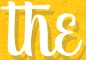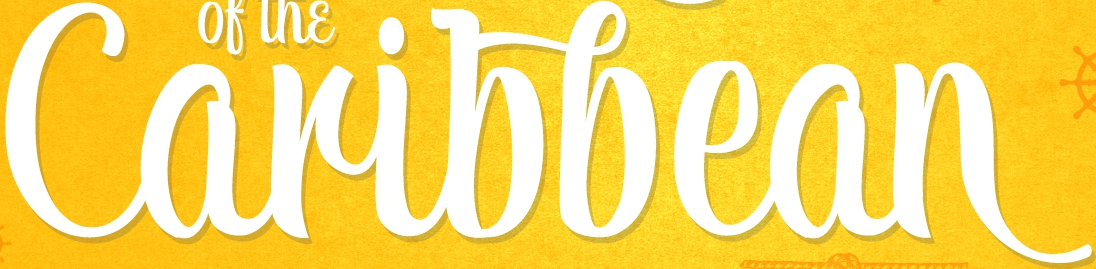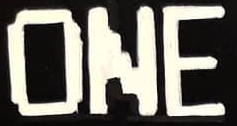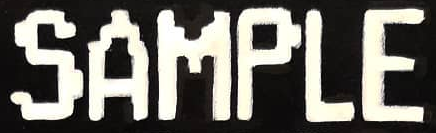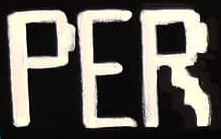Identify the words shown in these images in order, separated by a semicolon. the; Caribbean; ONE; SAMPLE; PER 